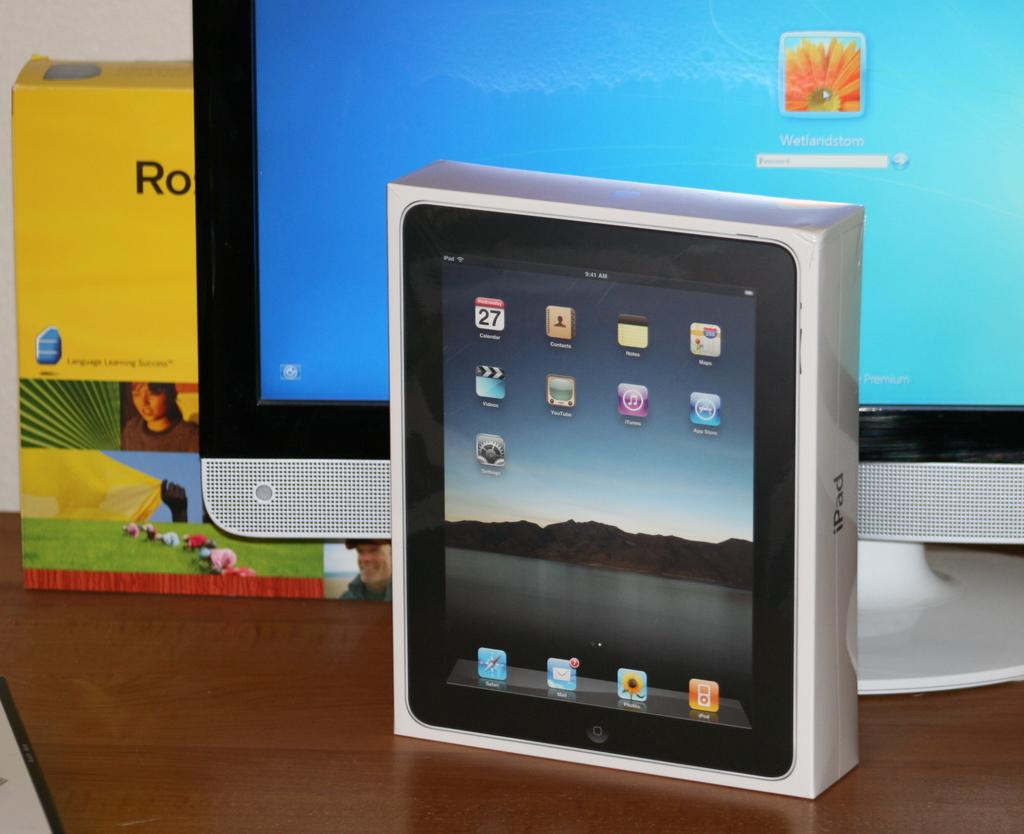What is the main object in the image? There is a gadget box in the image. What is located behind the gadget box? There is a monitor behind the gadget box. What is situated behind the monitor? There is another object behind the monitor. Where are these items placed? All these items are on a table. How many cents are visible on the gadget box in the image? There are no cents visible on the gadget box in the image. What is the woman doing in the image? There is no woman present in the image. 